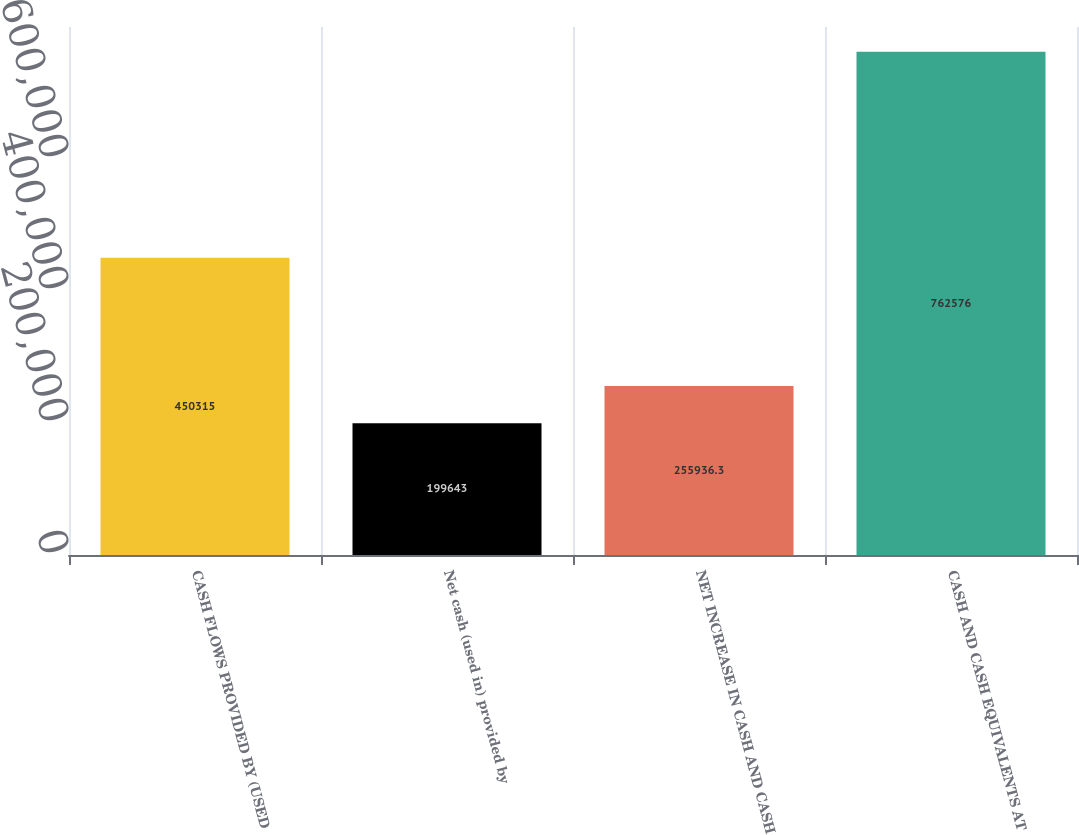<chart> <loc_0><loc_0><loc_500><loc_500><bar_chart><fcel>CASH FLOWS PROVIDED BY (USED<fcel>Net cash (used in) provided by<fcel>NET INCREASE IN CASH AND CASH<fcel>CASH AND CASH EQUIVALENTS AT<nl><fcel>450315<fcel>199643<fcel>255936<fcel>762576<nl></chart> 